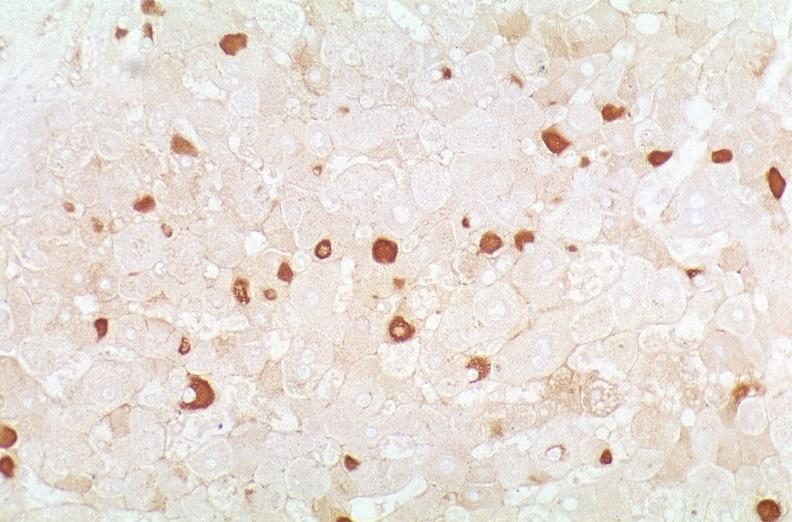s infarcts present?
Answer the question using a single word or phrase. No 